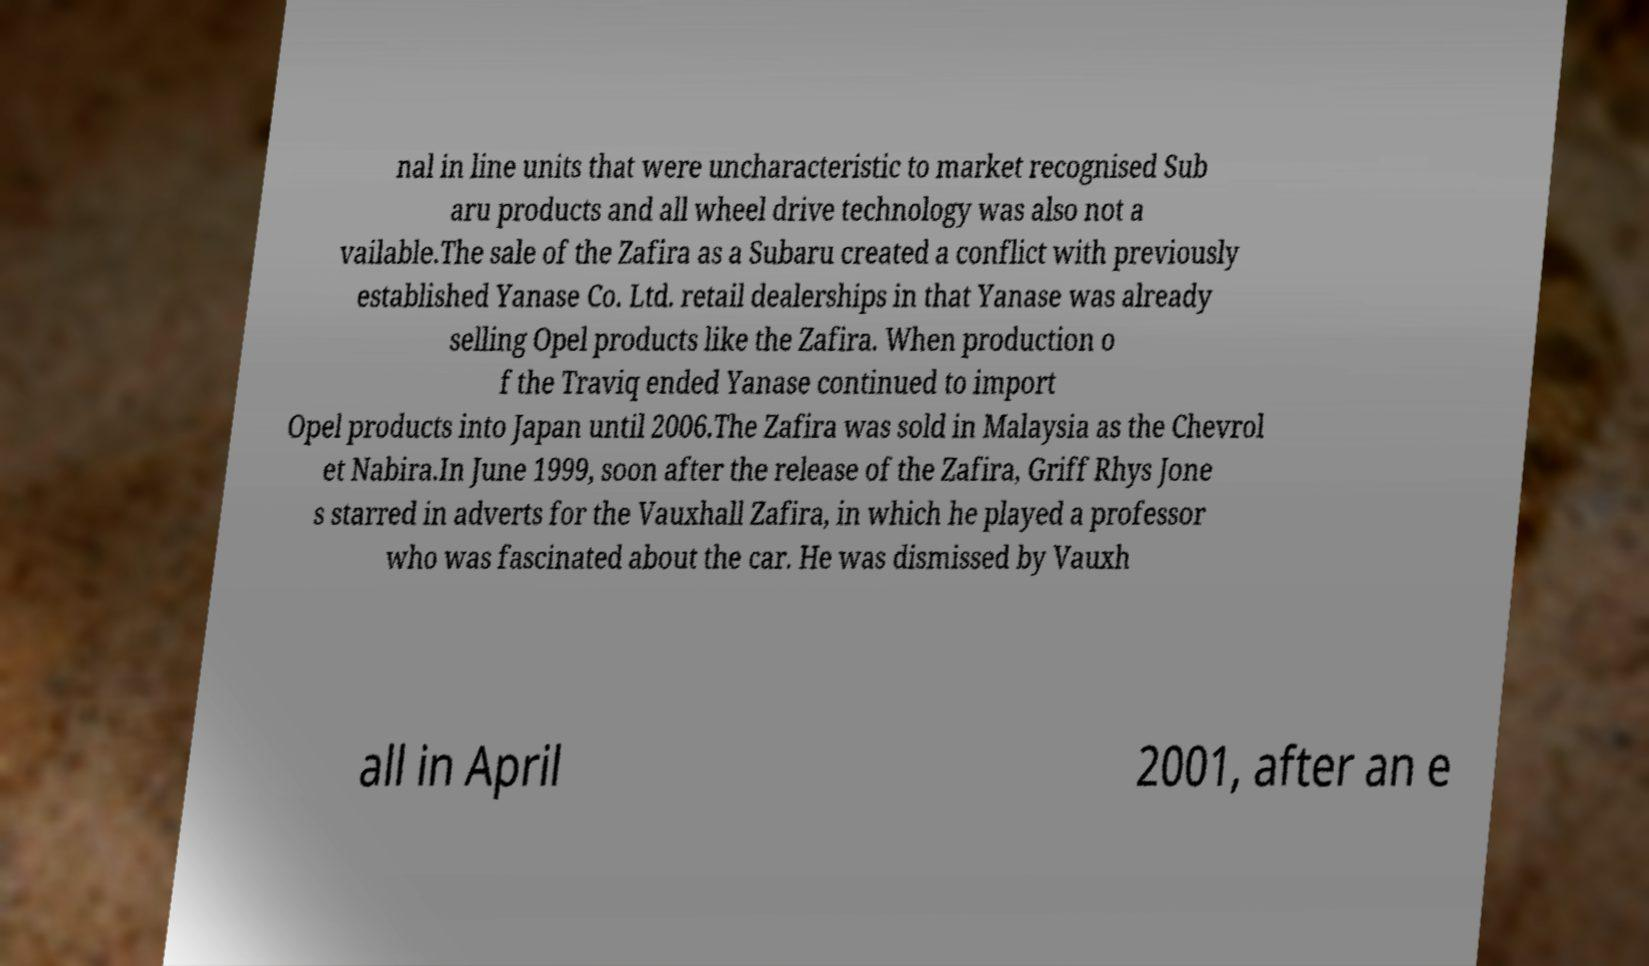For documentation purposes, I need the text within this image transcribed. Could you provide that? nal in line units that were uncharacteristic to market recognised Sub aru products and all wheel drive technology was also not a vailable.The sale of the Zafira as a Subaru created a conflict with previously established Yanase Co. Ltd. retail dealerships in that Yanase was already selling Opel products like the Zafira. When production o f the Traviq ended Yanase continued to import Opel products into Japan until 2006.The Zafira was sold in Malaysia as the Chevrol et Nabira.In June 1999, soon after the release of the Zafira, Griff Rhys Jone s starred in adverts for the Vauxhall Zafira, in which he played a professor who was fascinated about the car. He was dismissed by Vauxh all in April 2001, after an e 